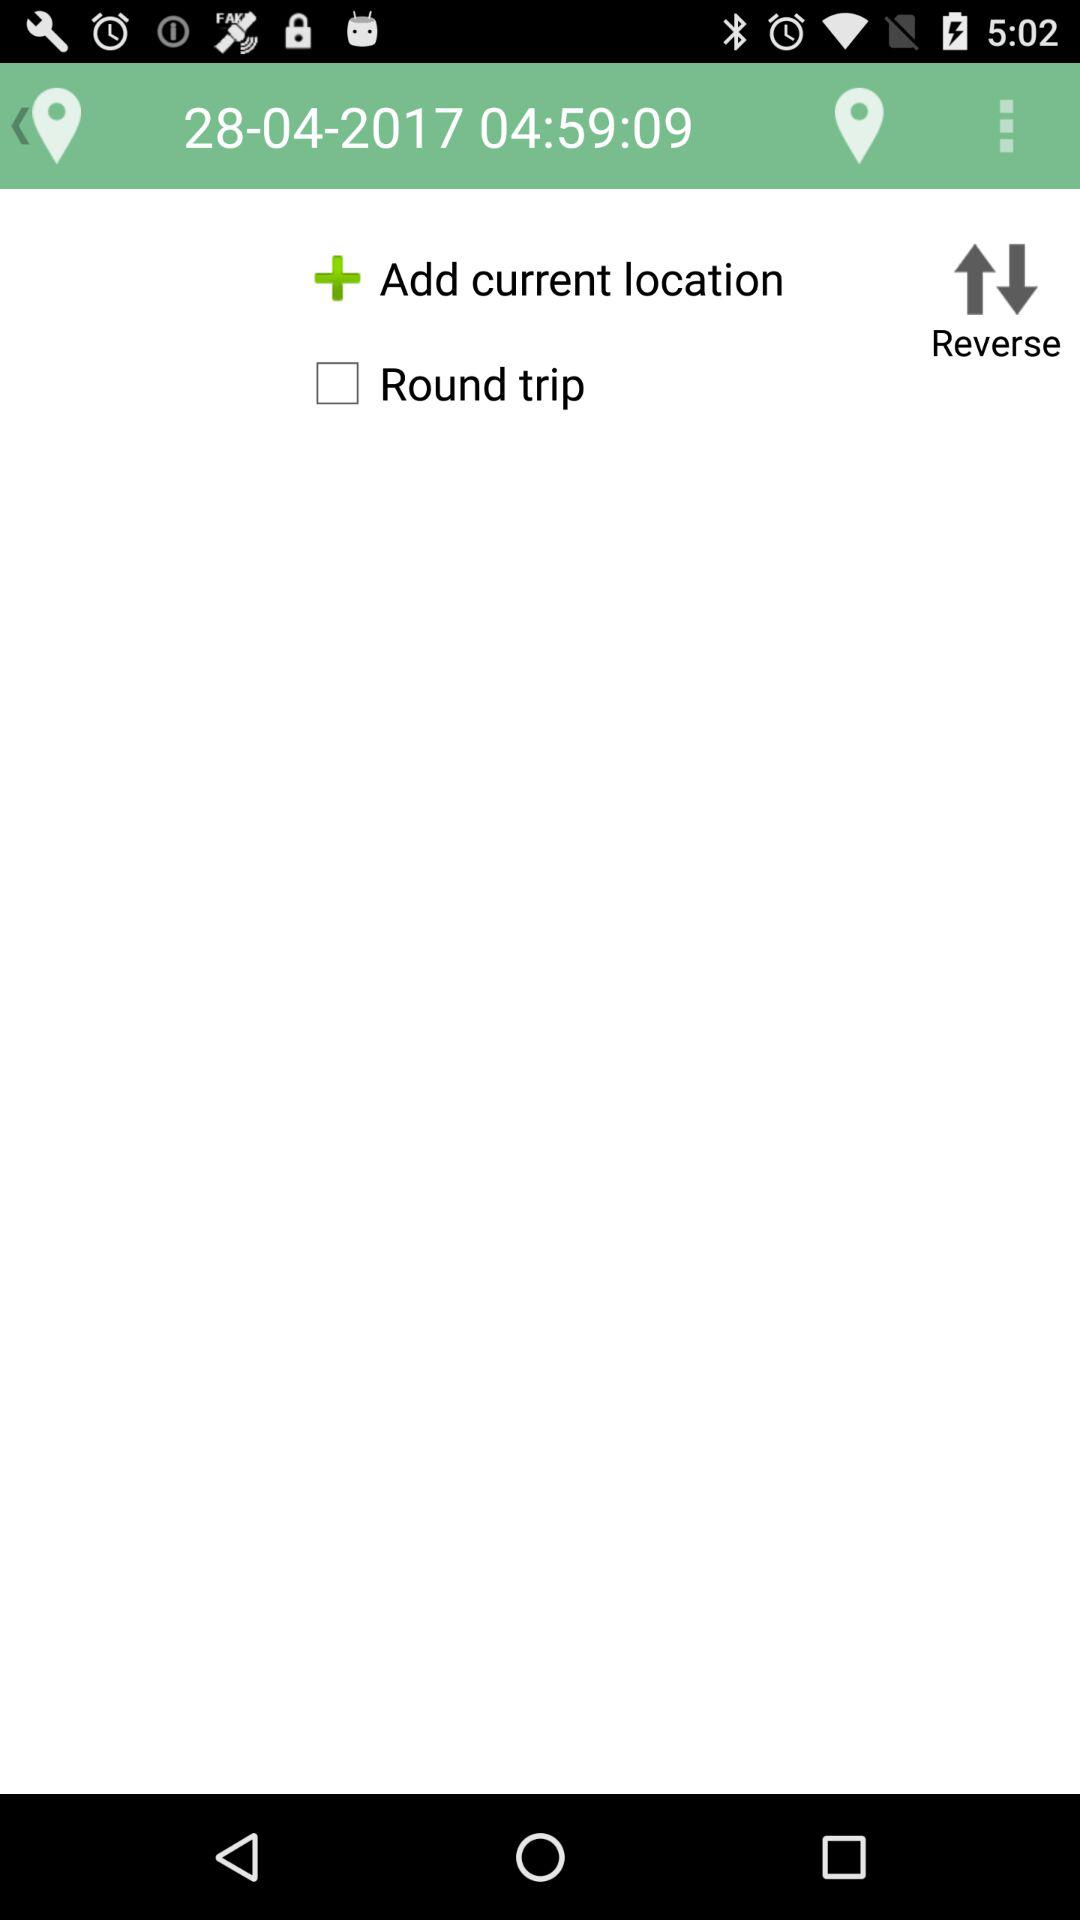What time is given? The given time is 04:59:09. 